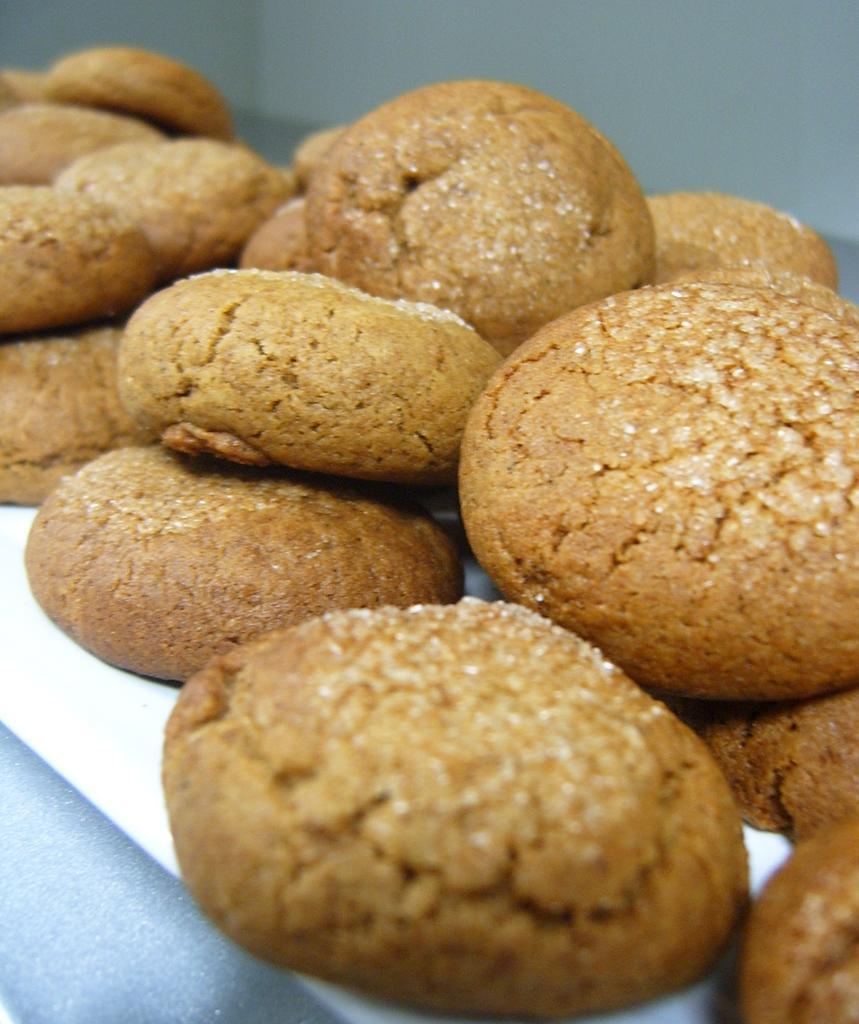Please provide a concise description of this image. In this picture we can see food and blurry background. 